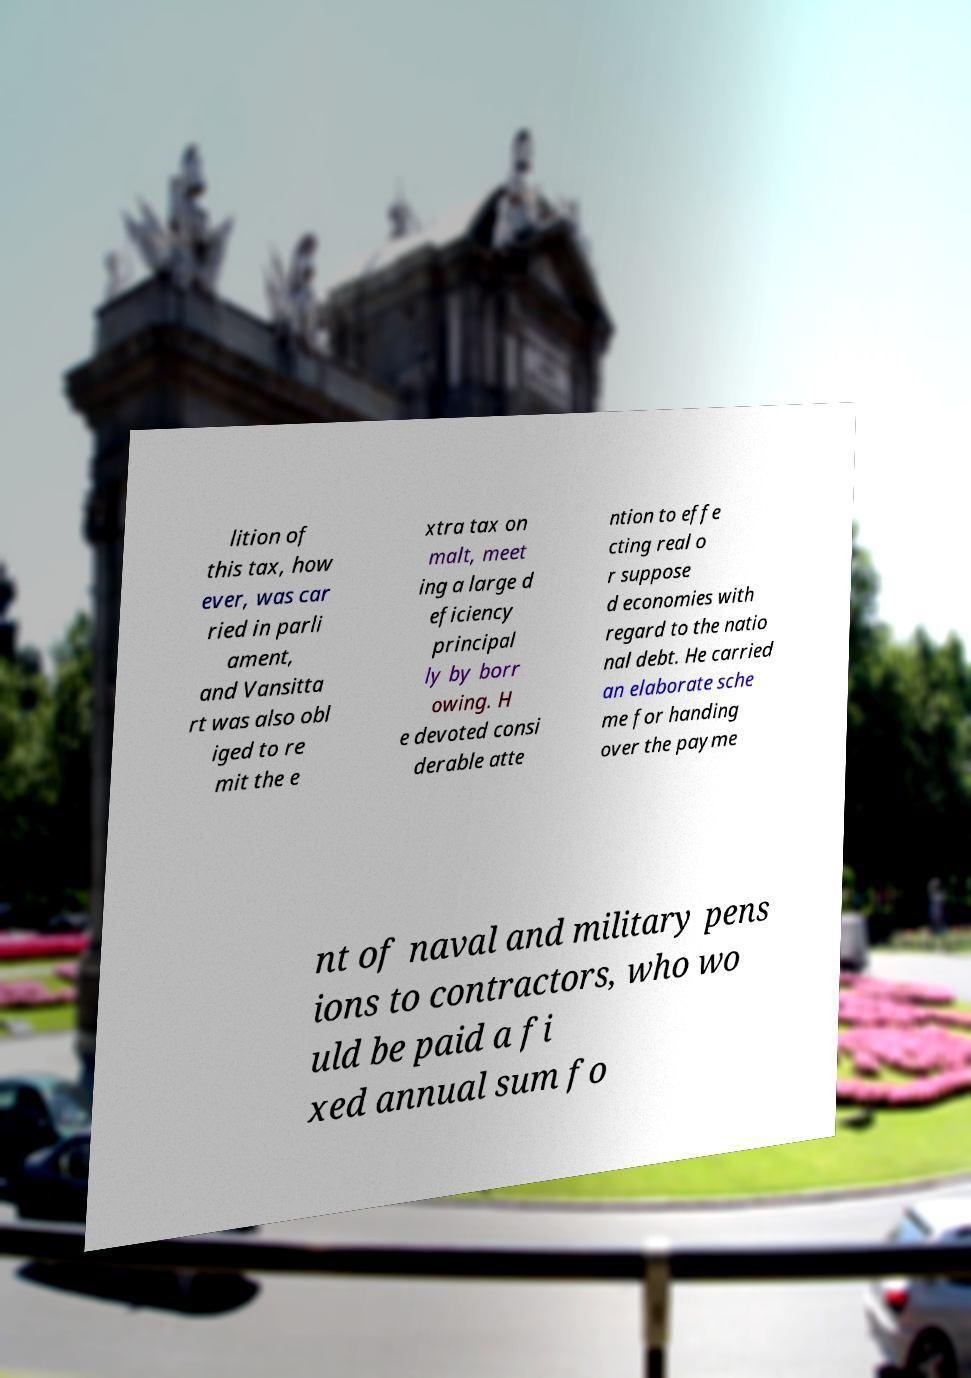Could you assist in decoding the text presented in this image and type it out clearly? lition of this tax, how ever, was car ried in parli ament, and Vansitta rt was also obl iged to re mit the e xtra tax on malt, meet ing a large d eficiency principal ly by borr owing. H e devoted consi derable atte ntion to effe cting real o r suppose d economies with regard to the natio nal debt. He carried an elaborate sche me for handing over the payme nt of naval and military pens ions to contractors, who wo uld be paid a fi xed annual sum fo 